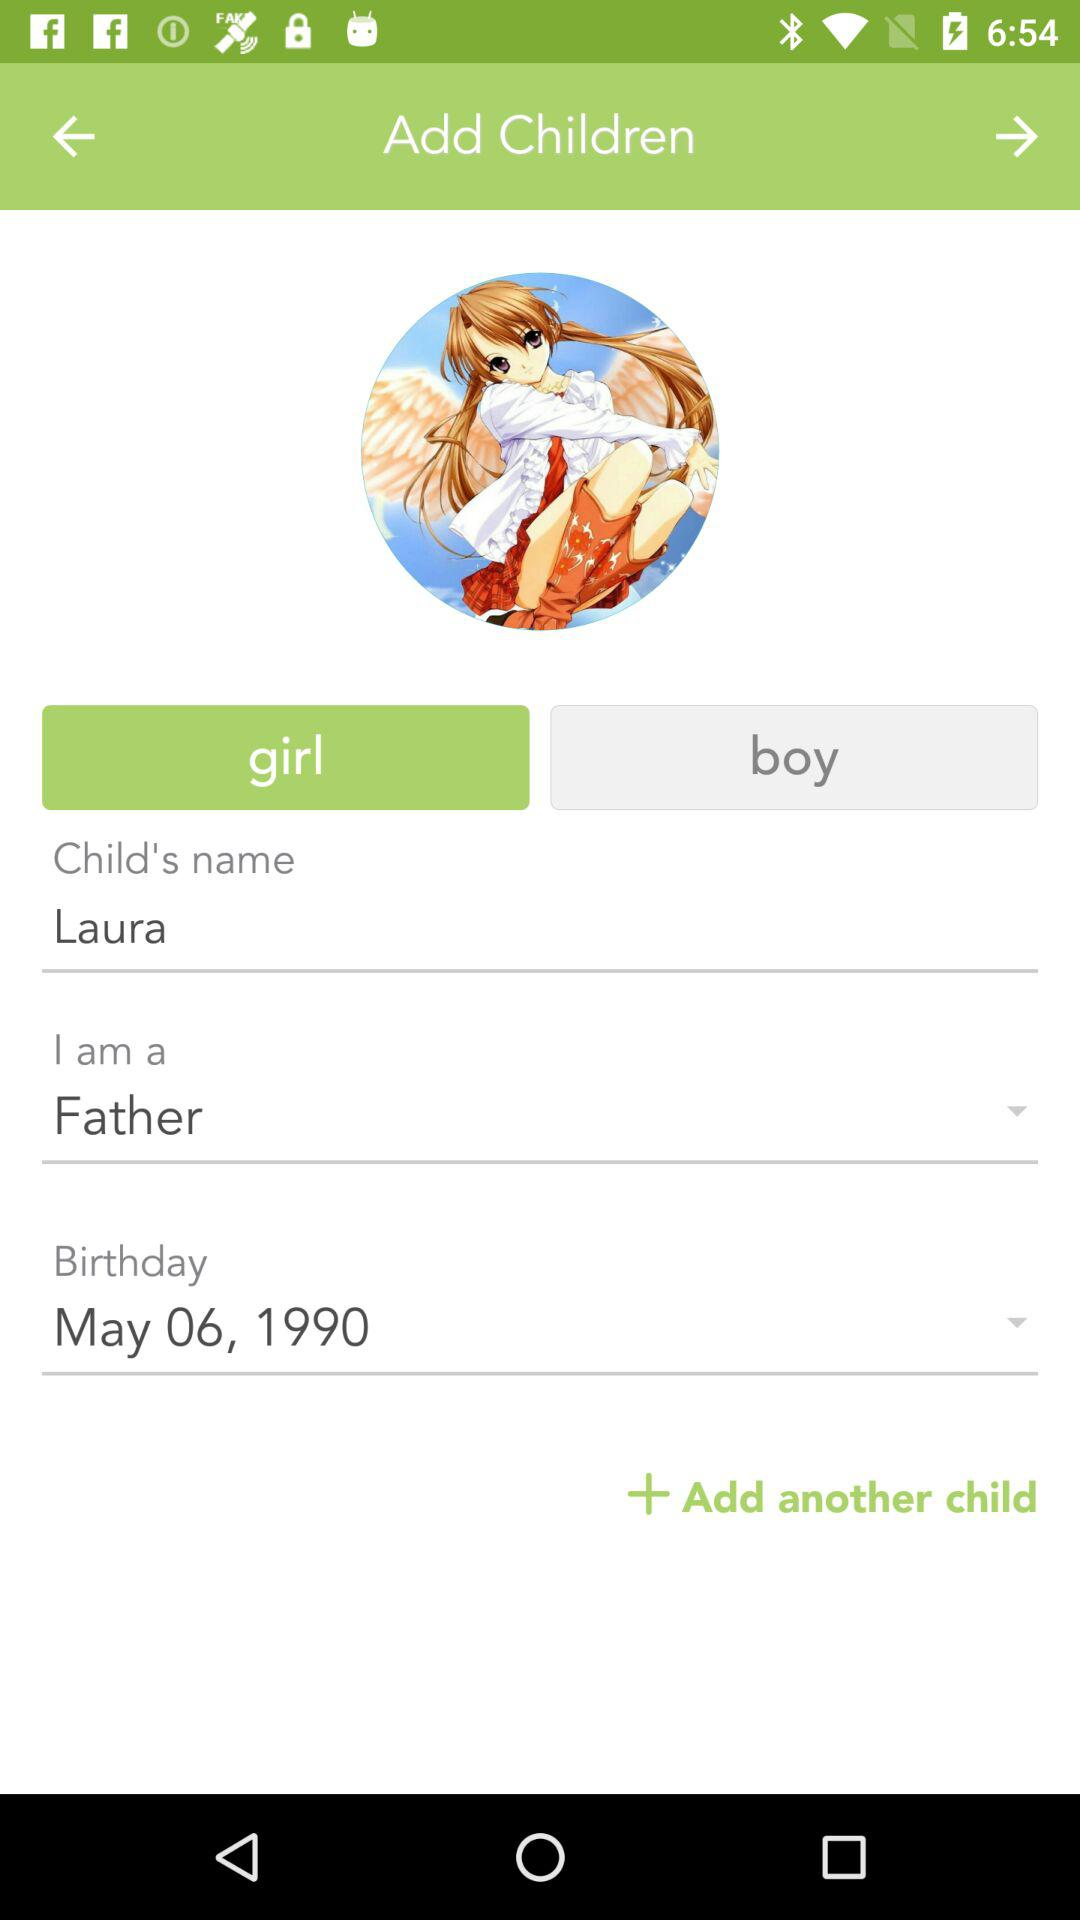What is the child's date of birth? The child's date of birth is May 6, 1990. 